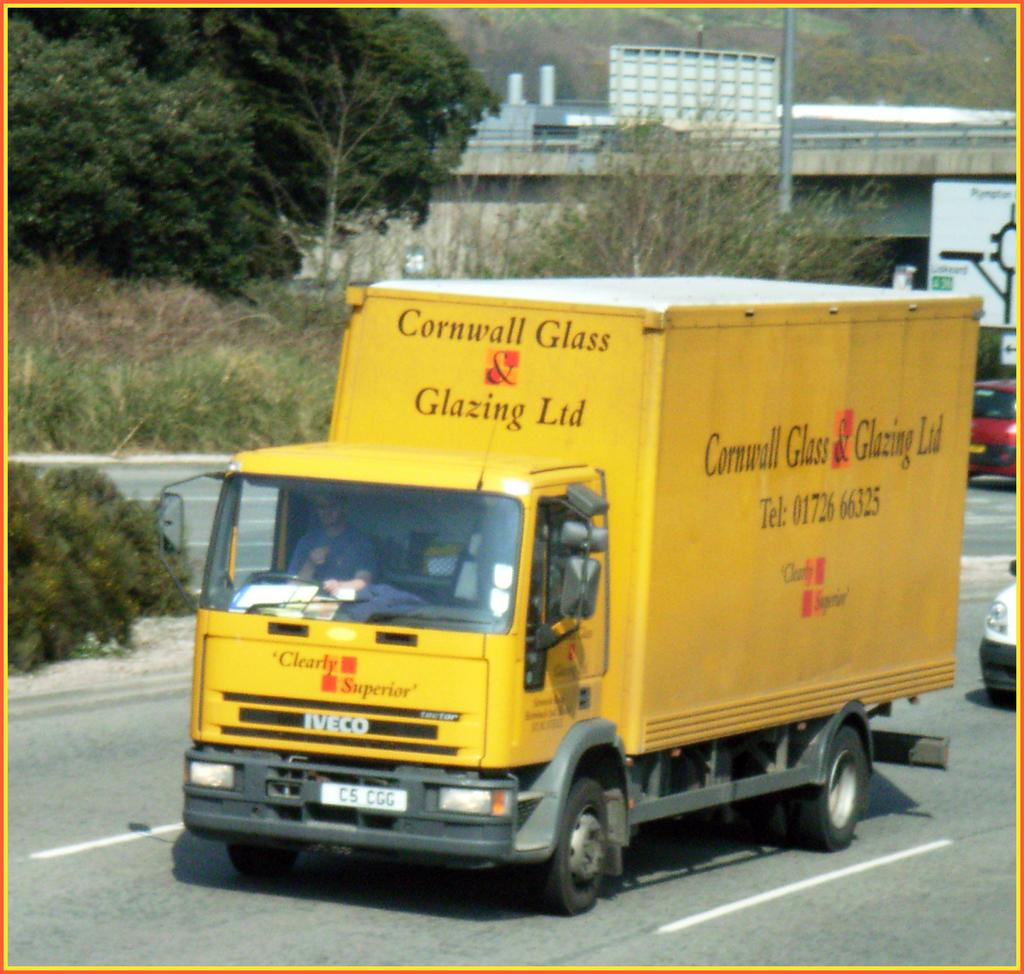What can be seen on the road in the image? There are vehicles on the road in the image. What type of vegetation is visible in the image? A: There are plants and trees visible in the image. How many dolls are sitting on the quartz in the image? There are no dolls or quartz present in the image. What type of work is the farmer doing in the image? There is no farmer present in the image. 